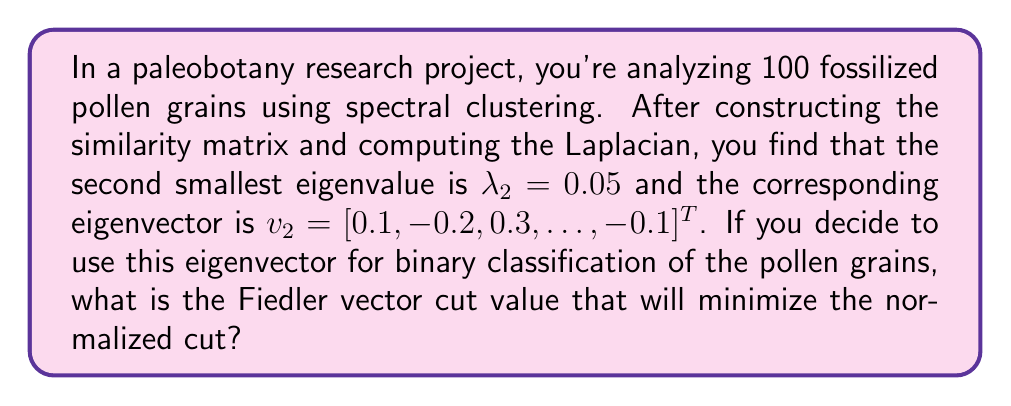Teach me how to tackle this problem. To solve this problem, we'll follow these steps:

1) The Fiedler vector is the eigenvector corresponding to the second smallest eigenvalue of the graph Laplacian. In this case, it's $v_2$.

2) For binary classification using spectral clustering, we typically use the median value of the Fiedler vector as the cut value. This approach tends to minimize the normalized cut.

3) To find the median, we need to sort the elements of $v_2$ and select the middle value. However, since we don't have all the elements, we can't determine the exact median.

4) Instead, we can use the fact that the Fiedler vector often has a mean of approximately zero. This is because it's orthogonal to the constant vector (the eigenvector corresponding to the smallest eigenvalue).

5) Given this property, the optimal cut value is typically very close to zero.

6) Therefore, the cut value that will minimize the normalized cut is approximately 0.

Note: In practice, you would compute the exact median of the Fiedler vector for the most accurate result. The approximation of 0 is based on theoretical properties of the Fiedler vector in many graph structures.
Answer: 0 